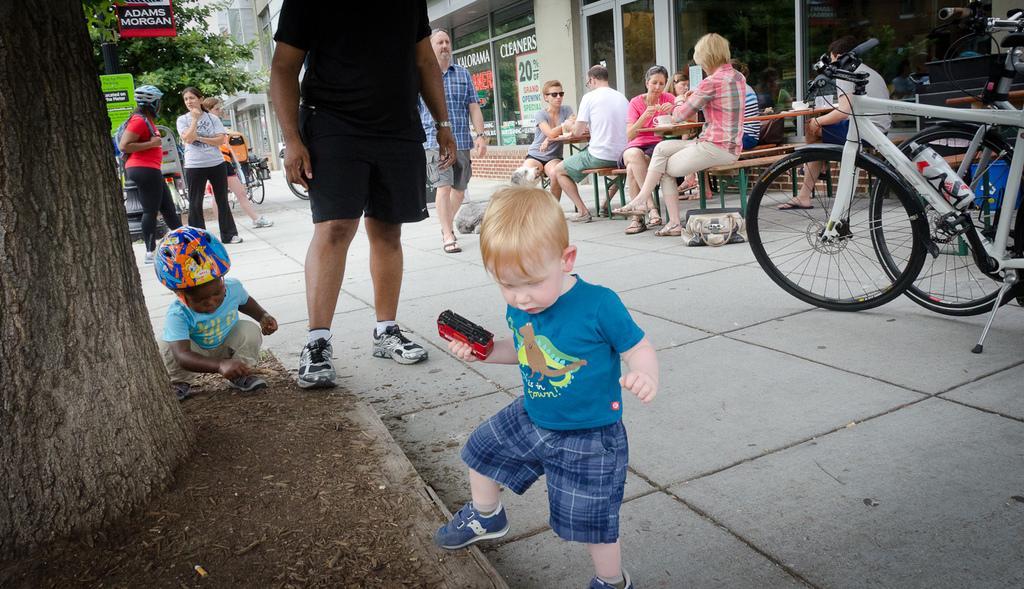In one or two sentences, can you explain what this image depicts? In this image we can see some buildings, some people are sitting, some benches with tables, some objects on the table, some people are standing, some trees, some people are walking, one bag on the floor, some people holding some objects, some bicycles, one dustbin, two children playing near the tree, one black pole, some banners, some text and one poster attached to the building glass. 